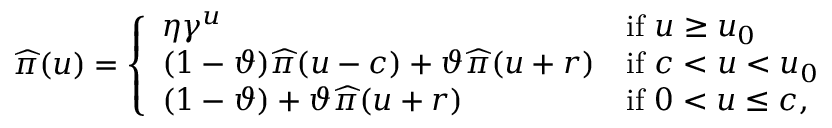Convert formula to latex. <formula><loc_0><loc_0><loc_500><loc_500>\widehat { \pi } ( u ) = \left \{ \begin{array} { l l } { \eta \gamma ^ { u } } & { i f u \geq u _ { 0 } } \\ { ( 1 - \vartheta ) \widehat { \pi } ( u - c ) + \vartheta \widehat { \pi } ( u + r ) } & { i f c < u < u _ { 0 } } \\ { ( 1 - \vartheta ) + \vartheta \widehat { \pi } ( u + r ) } & { i f 0 < u \leq c , } \end{array}</formula> 